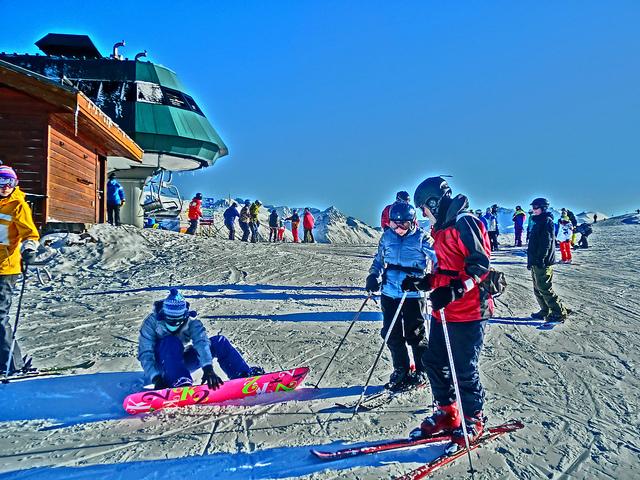What is different between the sitting and standing people's ski equipment?
Write a very short answer. Snowboard. How many people are sitting?
Keep it brief. 1. What activity is this?
Short answer required. Skiing. 